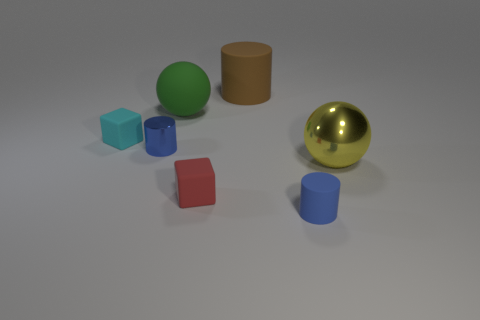There is a yellow metal thing; how many big yellow spheres are left of it?
Provide a succinct answer. 0. There is a small cylinder left of the brown cylinder; does it have the same color as the small matte cylinder?
Your answer should be very brief. Yes. How many yellow things are either tiny objects or matte blocks?
Your response must be concise. 0. What is the color of the thing left of the blue thing that is left of the tiny blue matte cylinder?
Keep it short and to the point. Cyan. What material is the small object that is the same color as the shiny cylinder?
Make the answer very short. Rubber. What is the color of the large sphere to the left of the yellow shiny ball?
Your answer should be compact. Green. Is the size of the cube behind the blue metal object the same as the big yellow object?
Your response must be concise. No. Is there a yellow object of the same size as the brown thing?
Keep it short and to the point. Yes. Does the matte cylinder in front of the big green rubber sphere have the same color as the cylinder that is to the left of the matte ball?
Give a very brief answer. Yes. Is there another cylinder that has the same color as the tiny rubber cylinder?
Keep it short and to the point. Yes. 